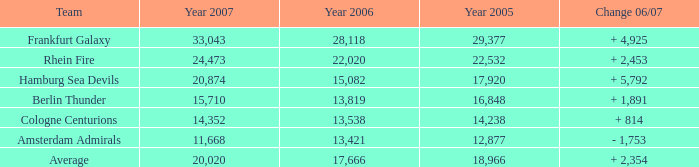Could you parse the entire table? {'header': ['Team', 'Year 2007', 'Year 2006', 'Year 2005', 'Change 06/07'], 'rows': [['Frankfurt Galaxy', '33,043', '28,118', '29,377', '+ 4,925'], ['Rhein Fire', '24,473', '22,020', '22,532', '+ 2,453'], ['Hamburg Sea Devils', '20,874', '15,082', '17,920', '+ 5,792'], ['Berlin Thunder', '15,710', '13,819', '16,848', '+ 1,891'], ['Cologne Centurions', '14,352', '13,538', '14,238', '+ 814'], ['Amsterdam Admirals', '11,668', '13,421', '12,877', '- 1,753'], ['Average', '20,020', '17,666', '18,966', '+ 2,354']]} What is the Team, when the Year 2007 is greater than 15,710, when the Year 2006 is greater than 17,666, and when the Year 2005 is greater than 22,532? Frankfurt Galaxy. 